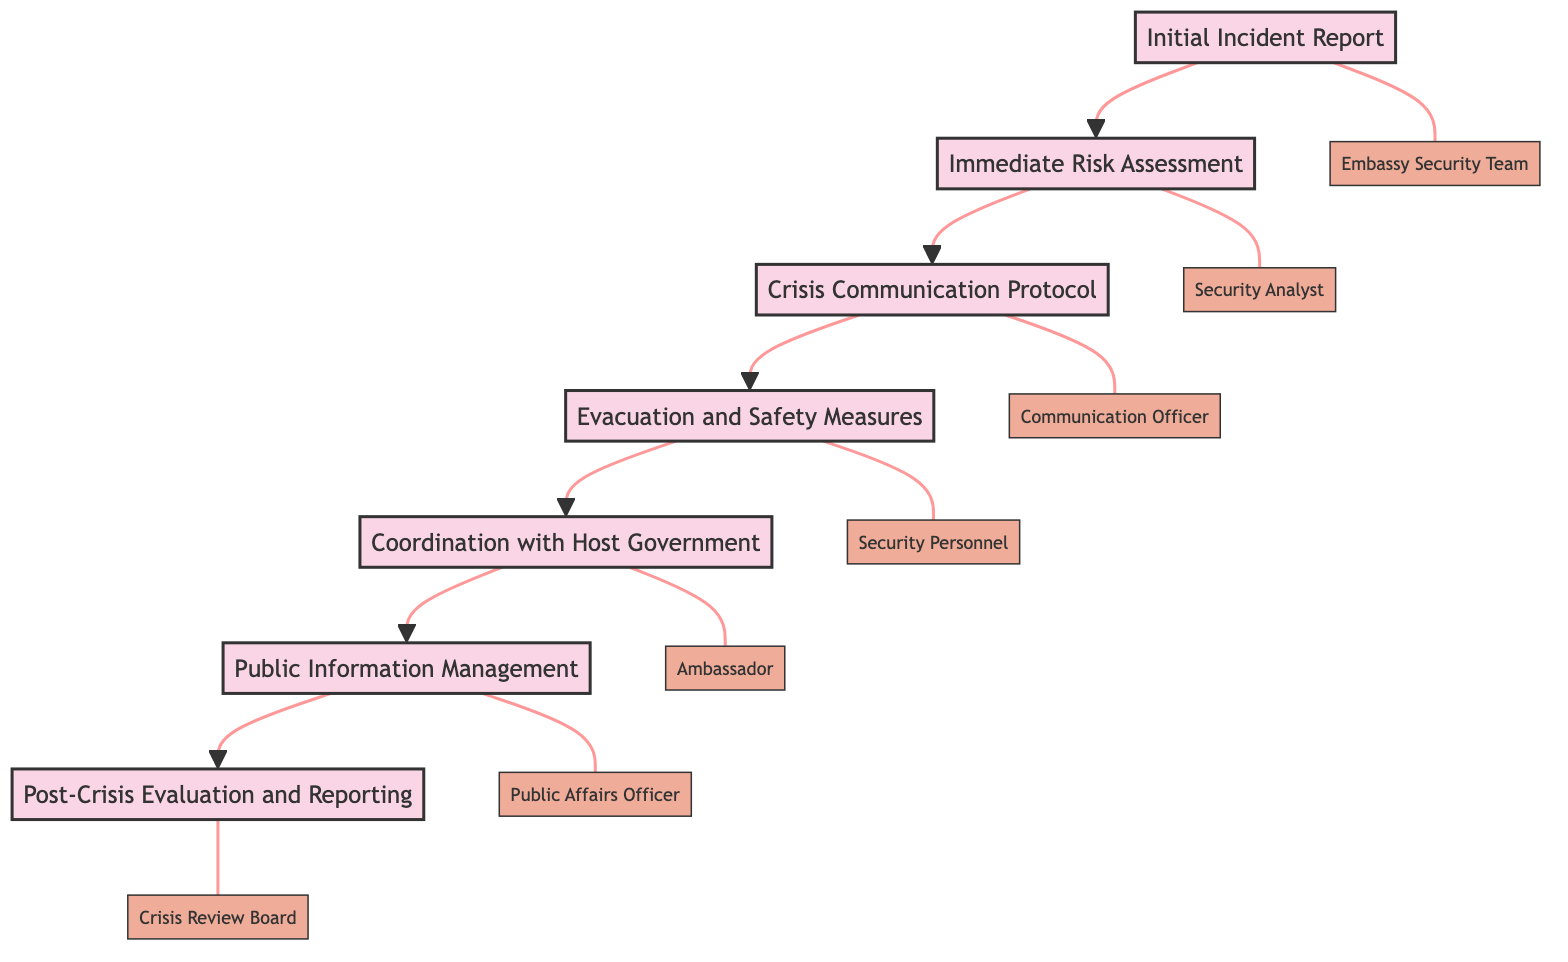What is the first step in the crisis response protocol? The diagram shows the first step as "Initial Incident Report" which indicates the starting point of the protocol.
Answer: Initial Incident Report How many total steps are there in the crisis response protocol? By counting the nodes in the diagram, there are seven distinct steps listed under the crisis response protocol.
Answer: 7 Who is responsible for the "Evacuation and Safety Measures"? The "Evacuation and Safety Measures" step indicates that "Security Personnel" are responsible for this action.
Answer: Security Personnel What is done after "Crisis Communication Protocol"? The flow in the diagram indicates that after "Crisis Communication Protocol," the next step is "Evacuation and Safety Measures."
Answer: Evacuation and Safety Measures Which step involves the engagement with local authorities? The diagram specifies that "Coordination with Host Government" involves engagement with local authorities to stabilize the situation.
Answer: Coordination with Host Government What are the entities involved in "Public Information Management"? The "Public Information Management" step lists "Public Affairs Officer," "Media Outlets," and "Social Media Analysts" as the associated entities.
Answer: Public Affairs Officer, Media Outlets, Social Media Analysts How does the protocol flow from "Immediate Risk Assessment"? The diagram shows that after "Immediate Risk Assessment," the flow moves to "Crisis Communication Protocol," indicating a sequential response in the protocol.
Answer: Crisis Communication Protocol What is the final step of the crisis response protocol? The last node in the flow of the diagram is "Post-Crisis Evaluation and Reporting," marking the conclusion of the protocol steps.
Answer: Post-Crisis Evaluation and Reporting Which entities correlate with the "Initial Incident Report"? The step "Initial Incident Report" connects with entities, specifically "Embassy Security Team," "Local Law Enforcement," and "SOS Alert System."
Answer: Embassy Security Team, Local Law Enforcement, SOS Alert System 